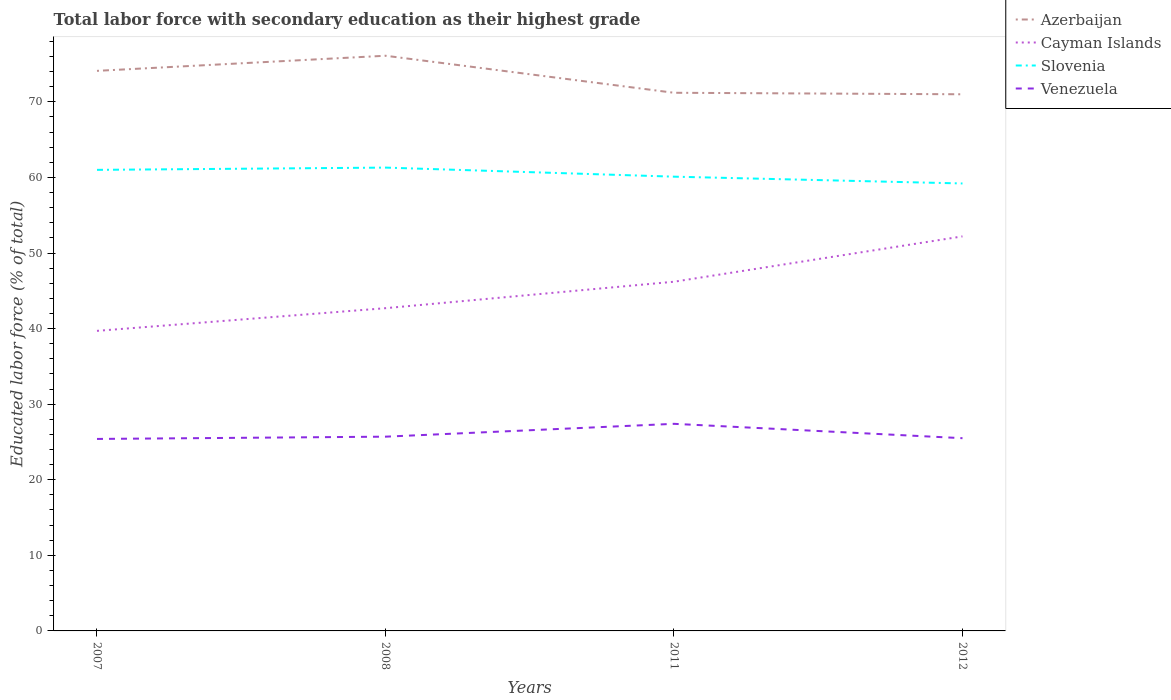Is the number of lines equal to the number of legend labels?
Offer a very short reply. Yes. Across all years, what is the maximum percentage of total labor force with primary education in Cayman Islands?
Give a very brief answer. 39.7. In which year was the percentage of total labor force with primary education in Venezuela maximum?
Ensure brevity in your answer.  2007. What is the total percentage of total labor force with primary education in Cayman Islands in the graph?
Offer a very short reply. -3.5. What is the difference between the highest and the lowest percentage of total labor force with primary education in Azerbaijan?
Your answer should be compact. 2. What is the difference between two consecutive major ticks on the Y-axis?
Provide a succinct answer. 10. Are the values on the major ticks of Y-axis written in scientific E-notation?
Ensure brevity in your answer.  No. Does the graph contain any zero values?
Offer a terse response. No. How many legend labels are there?
Your answer should be compact. 4. How are the legend labels stacked?
Provide a short and direct response. Vertical. What is the title of the graph?
Your answer should be compact. Total labor force with secondary education as their highest grade. Does "Middle East & North Africa (developing only)" appear as one of the legend labels in the graph?
Keep it short and to the point. No. What is the label or title of the X-axis?
Offer a terse response. Years. What is the label or title of the Y-axis?
Provide a succinct answer. Educated labor force (% of total). What is the Educated labor force (% of total) in Azerbaijan in 2007?
Ensure brevity in your answer.  74.1. What is the Educated labor force (% of total) of Cayman Islands in 2007?
Make the answer very short. 39.7. What is the Educated labor force (% of total) in Venezuela in 2007?
Provide a succinct answer. 25.4. What is the Educated labor force (% of total) in Azerbaijan in 2008?
Ensure brevity in your answer.  76.1. What is the Educated labor force (% of total) of Cayman Islands in 2008?
Provide a succinct answer. 42.7. What is the Educated labor force (% of total) of Slovenia in 2008?
Provide a succinct answer. 61.3. What is the Educated labor force (% of total) in Venezuela in 2008?
Keep it short and to the point. 25.7. What is the Educated labor force (% of total) in Azerbaijan in 2011?
Your response must be concise. 71.2. What is the Educated labor force (% of total) of Cayman Islands in 2011?
Keep it short and to the point. 46.2. What is the Educated labor force (% of total) in Slovenia in 2011?
Ensure brevity in your answer.  60.1. What is the Educated labor force (% of total) in Venezuela in 2011?
Provide a short and direct response. 27.4. What is the Educated labor force (% of total) in Cayman Islands in 2012?
Offer a terse response. 52.2. What is the Educated labor force (% of total) of Slovenia in 2012?
Give a very brief answer. 59.2. What is the Educated labor force (% of total) in Venezuela in 2012?
Provide a short and direct response. 25.5. Across all years, what is the maximum Educated labor force (% of total) of Azerbaijan?
Keep it short and to the point. 76.1. Across all years, what is the maximum Educated labor force (% of total) of Cayman Islands?
Your response must be concise. 52.2. Across all years, what is the maximum Educated labor force (% of total) in Slovenia?
Offer a very short reply. 61.3. Across all years, what is the maximum Educated labor force (% of total) of Venezuela?
Offer a terse response. 27.4. Across all years, what is the minimum Educated labor force (% of total) of Cayman Islands?
Provide a succinct answer. 39.7. Across all years, what is the minimum Educated labor force (% of total) in Slovenia?
Your response must be concise. 59.2. Across all years, what is the minimum Educated labor force (% of total) of Venezuela?
Offer a terse response. 25.4. What is the total Educated labor force (% of total) in Azerbaijan in the graph?
Your response must be concise. 292.4. What is the total Educated labor force (% of total) in Cayman Islands in the graph?
Provide a short and direct response. 180.8. What is the total Educated labor force (% of total) in Slovenia in the graph?
Give a very brief answer. 241.6. What is the total Educated labor force (% of total) in Venezuela in the graph?
Keep it short and to the point. 104. What is the difference between the Educated labor force (% of total) in Azerbaijan in 2007 and that in 2008?
Offer a terse response. -2. What is the difference between the Educated labor force (% of total) of Slovenia in 2007 and that in 2008?
Offer a terse response. -0.3. What is the difference between the Educated labor force (% of total) of Venezuela in 2007 and that in 2008?
Your answer should be very brief. -0.3. What is the difference between the Educated labor force (% of total) in Cayman Islands in 2007 and that in 2011?
Your response must be concise. -6.5. What is the difference between the Educated labor force (% of total) of Slovenia in 2007 and that in 2011?
Give a very brief answer. 0.9. What is the difference between the Educated labor force (% of total) in Venezuela in 2007 and that in 2011?
Make the answer very short. -2. What is the difference between the Educated labor force (% of total) in Azerbaijan in 2007 and that in 2012?
Make the answer very short. 3.1. What is the difference between the Educated labor force (% of total) of Cayman Islands in 2007 and that in 2012?
Make the answer very short. -12.5. What is the difference between the Educated labor force (% of total) of Slovenia in 2008 and that in 2011?
Your answer should be compact. 1.2. What is the difference between the Educated labor force (% of total) of Venezuela in 2008 and that in 2011?
Provide a succinct answer. -1.7. What is the difference between the Educated labor force (% of total) in Cayman Islands in 2008 and that in 2012?
Your response must be concise. -9.5. What is the difference between the Educated labor force (% of total) of Slovenia in 2008 and that in 2012?
Offer a terse response. 2.1. What is the difference between the Educated labor force (% of total) in Venezuela in 2008 and that in 2012?
Offer a terse response. 0.2. What is the difference between the Educated labor force (% of total) in Slovenia in 2011 and that in 2012?
Offer a very short reply. 0.9. What is the difference between the Educated labor force (% of total) of Azerbaijan in 2007 and the Educated labor force (% of total) of Cayman Islands in 2008?
Provide a succinct answer. 31.4. What is the difference between the Educated labor force (% of total) in Azerbaijan in 2007 and the Educated labor force (% of total) in Venezuela in 2008?
Keep it short and to the point. 48.4. What is the difference between the Educated labor force (% of total) of Cayman Islands in 2007 and the Educated labor force (% of total) of Slovenia in 2008?
Give a very brief answer. -21.6. What is the difference between the Educated labor force (% of total) in Cayman Islands in 2007 and the Educated labor force (% of total) in Venezuela in 2008?
Give a very brief answer. 14. What is the difference between the Educated labor force (% of total) in Slovenia in 2007 and the Educated labor force (% of total) in Venezuela in 2008?
Keep it short and to the point. 35.3. What is the difference between the Educated labor force (% of total) of Azerbaijan in 2007 and the Educated labor force (% of total) of Cayman Islands in 2011?
Offer a terse response. 27.9. What is the difference between the Educated labor force (% of total) in Azerbaijan in 2007 and the Educated labor force (% of total) in Slovenia in 2011?
Provide a succinct answer. 14. What is the difference between the Educated labor force (% of total) of Azerbaijan in 2007 and the Educated labor force (% of total) of Venezuela in 2011?
Ensure brevity in your answer.  46.7. What is the difference between the Educated labor force (% of total) in Cayman Islands in 2007 and the Educated labor force (% of total) in Slovenia in 2011?
Provide a succinct answer. -20.4. What is the difference between the Educated labor force (% of total) in Slovenia in 2007 and the Educated labor force (% of total) in Venezuela in 2011?
Provide a succinct answer. 33.6. What is the difference between the Educated labor force (% of total) in Azerbaijan in 2007 and the Educated labor force (% of total) in Cayman Islands in 2012?
Offer a very short reply. 21.9. What is the difference between the Educated labor force (% of total) of Azerbaijan in 2007 and the Educated labor force (% of total) of Slovenia in 2012?
Your response must be concise. 14.9. What is the difference between the Educated labor force (% of total) in Azerbaijan in 2007 and the Educated labor force (% of total) in Venezuela in 2012?
Your answer should be compact. 48.6. What is the difference between the Educated labor force (% of total) of Cayman Islands in 2007 and the Educated labor force (% of total) of Slovenia in 2012?
Keep it short and to the point. -19.5. What is the difference between the Educated labor force (% of total) of Slovenia in 2007 and the Educated labor force (% of total) of Venezuela in 2012?
Your response must be concise. 35.5. What is the difference between the Educated labor force (% of total) in Azerbaijan in 2008 and the Educated labor force (% of total) in Cayman Islands in 2011?
Your response must be concise. 29.9. What is the difference between the Educated labor force (% of total) of Azerbaijan in 2008 and the Educated labor force (% of total) of Slovenia in 2011?
Make the answer very short. 16. What is the difference between the Educated labor force (% of total) in Azerbaijan in 2008 and the Educated labor force (% of total) in Venezuela in 2011?
Offer a very short reply. 48.7. What is the difference between the Educated labor force (% of total) of Cayman Islands in 2008 and the Educated labor force (% of total) of Slovenia in 2011?
Give a very brief answer. -17.4. What is the difference between the Educated labor force (% of total) of Cayman Islands in 2008 and the Educated labor force (% of total) of Venezuela in 2011?
Give a very brief answer. 15.3. What is the difference between the Educated labor force (% of total) of Slovenia in 2008 and the Educated labor force (% of total) of Venezuela in 2011?
Ensure brevity in your answer.  33.9. What is the difference between the Educated labor force (% of total) in Azerbaijan in 2008 and the Educated labor force (% of total) in Cayman Islands in 2012?
Make the answer very short. 23.9. What is the difference between the Educated labor force (% of total) of Azerbaijan in 2008 and the Educated labor force (% of total) of Slovenia in 2012?
Keep it short and to the point. 16.9. What is the difference between the Educated labor force (% of total) in Azerbaijan in 2008 and the Educated labor force (% of total) in Venezuela in 2012?
Ensure brevity in your answer.  50.6. What is the difference between the Educated labor force (% of total) in Cayman Islands in 2008 and the Educated labor force (% of total) in Slovenia in 2012?
Provide a short and direct response. -16.5. What is the difference between the Educated labor force (% of total) of Cayman Islands in 2008 and the Educated labor force (% of total) of Venezuela in 2012?
Keep it short and to the point. 17.2. What is the difference between the Educated labor force (% of total) of Slovenia in 2008 and the Educated labor force (% of total) of Venezuela in 2012?
Offer a terse response. 35.8. What is the difference between the Educated labor force (% of total) in Azerbaijan in 2011 and the Educated labor force (% of total) in Slovenia in 2012?
Your answer should be very brief. 12. What is the difference between the Educated labor force (% of total) of Azerbaijan in 2011 and the Educated labor force (% of total) of Venezuela in 2012?
Your answer should be very brief. 45.7. What is the difference between the Educated labor force (% of total) of Cayman Islands in 2011 and the Educated labor force (% of total) of Slovenia in 2012?
Offer a terse response. -13. What is the difference between the Educated labor force (% of total) in Cayman Islands in 2011 and the Educated labor force (% of total) in Venezuela in 2012?
Ensure brevity in your answer.  20.7. What is the difference between the Educated labor force (% of total) of Slovenia in 2011 and the Educated labor force (% of total) of Venezuela in 2012?
Your answer should be very brief. 34.6. What is the average Educated labor force (% of total) in Azerbaijan per year?
Your answer should be compact. 73.1. What is the average Educated labor force (% of total) of Cayman Islands per year?
Your response must be concise. 45.2. What is the average Educated labor force (% of total) of Slovenia per year?
Provide a short and direct response. 60.4. What is the average Educated labor force (% of total) of Venezuela per year?
Offer a terse response. 26. In the year 2007, what is the difference between the Educated labor force (% of total) in Azerbaijan and Educated labor force (% of total) in Cayman Islands?
Your response must be concise. 34.4. In the year 2007, what is the difference between the Educated labor force (% of total) of Azerbaijan and Educated labor force (% of total) of Venezuela?
Offer a terse response. 48.7. In the year 2007, what is the difference between the Educated labor force (% of total) of Cayman Islands and Educated labor force (% of total) of Slovenia?
Offer a very short reply. -21.3. In the year 2007, what is the difference between the Educated labor force (% of total) of Cayman Islands and Educated labor force (% of total) of Venezuela?
Offer a terse response. 14.3. In the year 2007, what is the difference between the Educated labor force (% of total) of Slovenia and Educated labor force (% of total) of Venezuela?
Keep it short and to the point. 35.6. In the year 2008, what is the difference between the Educated labor force (% of total) of Azerbaijan and Educated labor force (% of total) of Cayman Islands?
Offer a terse response. 33.4. In the year 2008, what is the difference between the Educated labor force (% of total) of Azerbaijan and Educated labor force (% of total) of Venezuela?
Your answer should be very brief. 50.4. In the year 2008, what is the difference between the Educated labor force (% of total) in Cayman Islands and Educated labor force (% of total) in Slovenia?
Provide a short and direct response. -18.6. In the year 2008, what is the difference between the Educated labor force (% of total) of Slovenia and Educated labor force (% of total) of Venezuela?
Your answer should be compact. 35.6. In the year 2011, what is the difference between the Educated labor force (% of total) of Azerbaijan and Educated labor force (% of total) of Cayman Islands?
Offer a terse response. 25. In the year 2011, what is the difference between the Educated labor force (% of total) of Azerbaijan and Educated labor force (% of total) of Slovenia?
Ensure brevity in your answer.  11.1. In the year 2011, what is the difference between the Educated labor force (% of total) in Azerbaijan and Educated labor force (% of total) in Venezuela?
Ensure brevity in your answer.  43.8. In the year 2011, what is the difference between the Educated labor force (% of total) in Cayman Islands and Educated labor force (% of total) in Venezuela?
Give a very brief answer. 18.8. In the year 2011, what is the difference between the Educated labor force (% of total) of Slovenia and Educated labor force (% of total) of Venezuela?
Provide a succinct answer. 32.7. In the year 2012, what is the difference between the Educated labor force (% of total) in Azerbaijan and Educated labor force (% of total) in Cayman Islands?
Keep it short and to the point. 18.8. In the year 2012, what is the difference between the Educated labor force (% of total) of Azerbaijan and Educated labor force (% of total) of Slovenia?
Ensure brevity in your answer.  11.8. In the year 2012, what is the difference between the Educated labor force (% of total) of Azerbaijan and Educated labor force (% of total) of Venezuela?
Make the answer very short. 45.5. In the year 2012, what is the difference between the Educated labor force (% of total) in Cayman Islands and Educated labor force (% of total) in Venezuela?
Provide a short and direct response. 26.7. In the year 2012, what is the difference between the Educated labor force (% of total) of Slovenia and Educated labor force (% of total) of Venezuela?
Keep it short and to the point. 33.7. What is the ratio of the Educated labor force (% of total) of Azerbaijan in 2007 to that in 2008?
Provide a short and direct response. 0.97. What is the ratio of the Educated labor force (% of total) in Cayman Islands in 2007 to that in 2008?
Offer a very short reply. 0.93. What is the ratio of the Educated labor force (% of total) in Venezuela in 2007 to that in 2008?
Offer a terse response. 0.99. What is the ratio of the Educated labor force (% of total) of Azerbaijan in 2007 to that in 2011?
Ensure brevity in your answer.  1.04. What is the ratio of the Educated labor force (% of total) of Cayman Islands in 2007 to that in 2011?
Provide a succinct answer. 0.86. What is the ratio of the Educated labor force (% of total) in Slovenia in 2007 to that in 2011?
Keep it short and to the point. 1.01. What is the ratio of the Educated labor force (% of total) in Venezuela in 2007 to that in 2011?
Your answer should be very brief. 0.93. What is the ratio of the Educated labor force (% of total) in Azerbaijan in 2007 to that in 2012?
Make the answer very short. 1.04. What is the ratio of the Educated labor force (% of total) of Cayman Islands in 2007 to that in 2012?
Your response must be concise. 0.76. What is the ratio of the Educated labor force (% of total) of Slovenia in 2007 to that in 2012?
Provide a succinct answer. 1.03. What is the ratio of the Educated labor force (% of total) of Venezuela in 2007 to that in 2012?
Your answer should be compact. 1. What is the ratio of the Educated labor force (% of total) in Azerbaijan in 2008 to that in 2011?
Give a very brief answer. 1.07. What is the ratio of the Educated labor force (% of total) in Cayman Islands in 2008 to that in 2011?
Give a very brief answer. 0.92. What is the ratio of the Educated labor force (% of total) in Venezuela in 2008 to that in 2011?
Provide a short and direct response. 0.94. What is the ratio of the Educated labor force (% of total) in Azerbaijan in 2008 to that in 2012?
Give a very brief answer. 1.07. What is the ratio of the Educated labor force (% of total) in Cayman Islands in 2008 to that in 2012?
Your answer should be compact. 0.82. What is the ratio of the Educated labor force (% of total) in Slovenia in 2008 to that in 2012?
Provide a succinct answer. 1.04. What is the ratio of the Educated labor force (% of total) of Venezuela in 2008 to that in 2012?
Your answer should be very brief. 1.01. What is the ratio of the Educated labor force (% of total) of Azerbaijan in 2011 to that in 2012?
Offer a terse response. 1. What is the ratio of the Educated labor force (% of total) in Cayman Islands in 2011 to that in 2012?
Your response must be concise. 0.89. What is the ratio of the Educated labor force (% of total) in Slovenia in 2011 to that in 2012?
Your answer should be compact. 1.02. What is the ratio of the Educated labor force (% of total) in Venezuela in 2011 to that in 2012?
Give a very brief answer. 1.07. What is the difference between the highest and the second highest Educated labor force (% of total) in Cayman Islands?
Offer a very short reply. 6. What is the difference between the highest and the second highest Educated labor force (% of total) of Slovenia?
Make the answer very short. 0.3. What is the difference between the highest and the lowest Educated labor force (% of total) of Azerbaijan?
Make the answer very short. 5.1. 